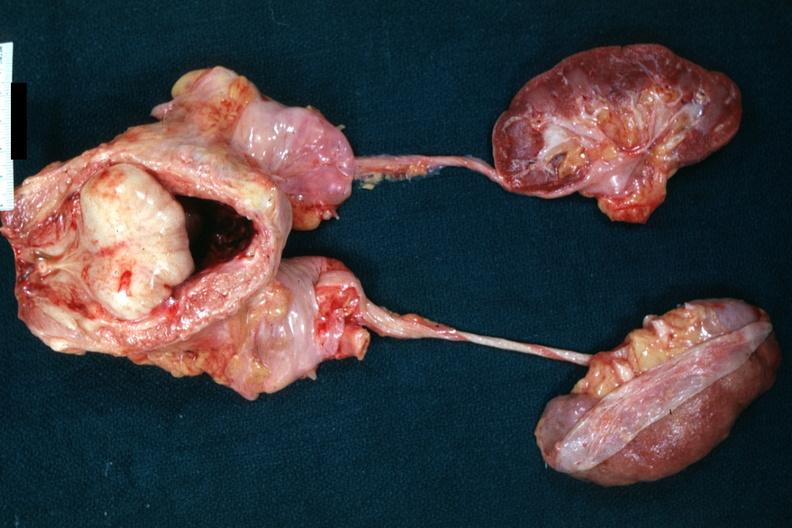does this image show massively enlarge nodular prostate with median lobe protrusion into floor of bladder, bladder hypertrophy, and normal appearing ureters and kidneys excellent example of bph?
Answer the question using a single word or phrase. Yes 